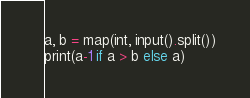<code> <loc_0><loc_0><loc_500><loc_500><_Python_>
a, b = map(int, input().split())
print(a-1 if a > b else a)</code> 